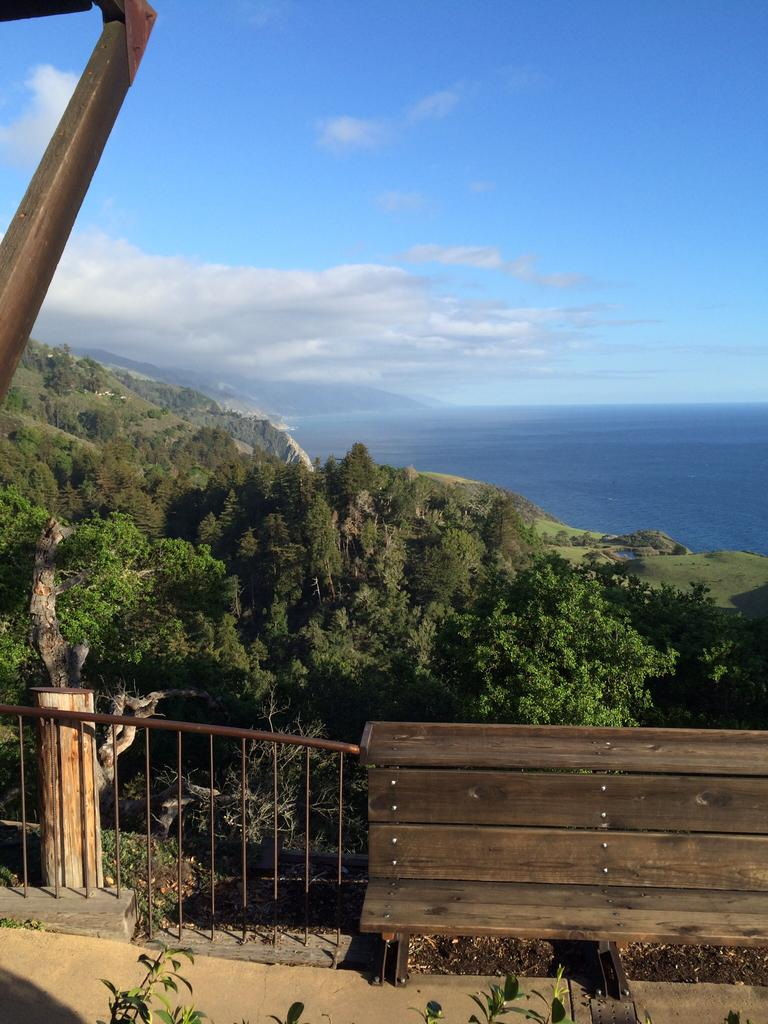What type of vegetation is in the middle of the image? There are trees in the middle of the image. What type of seating is located at the bottom of the image? There is a bench at the bottom of the image. What is visible at the top of the image? The sky is visible at the top of the image. What can be seen on the right side of the image? There is water on the right side of the image. What type of waste is present in the image? There is no waste present in the image. Can you tell me how many heads are visible in the image? There are no heads visible in the image. 